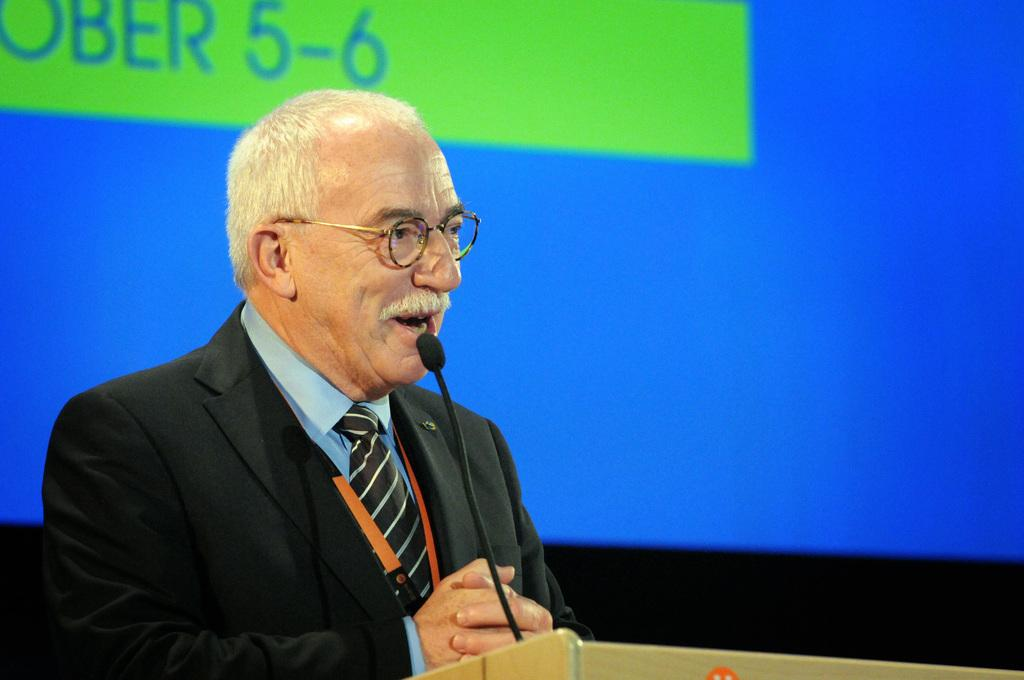Who or what is present in the image? There is a person in the image. What is the person near in the image? The person is near a podium. What object is visible in the image that is used for amplifying sound? There is a microphone in the image. What can be seen in the image that might display information or visuals? There is a screen in the image. How many grapes are on the person's mind in the image? There are no grapes or references to the person's mind in the image. 